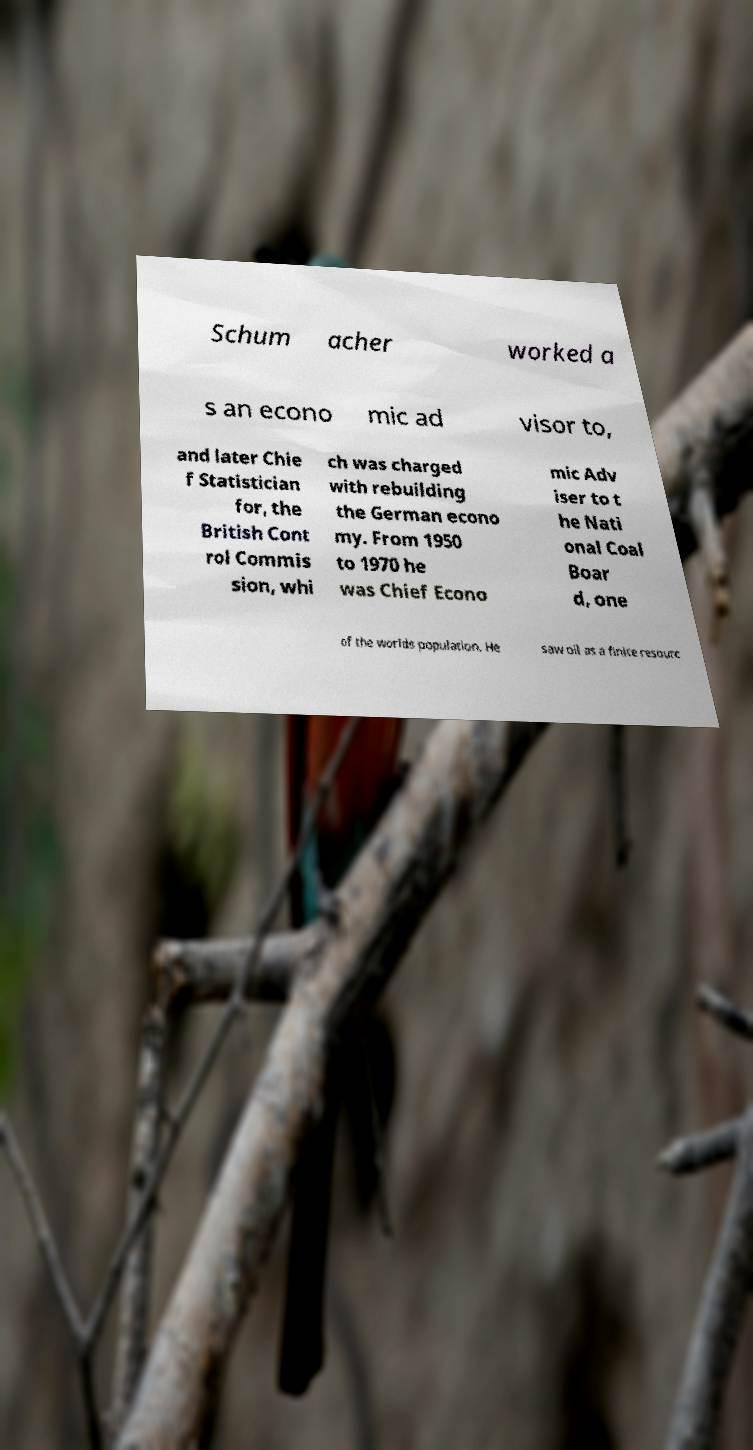I need the written content from this picture converted into text. Can you do that? Schum acher worked a s an econo mic ad visor to, and later Chie f Statistician for, the British Cont rol Commis sion, whi ch was charged with rebuilding the German econo my. From 1950 to 1970 he was Chief Econo mic Adv iser to t he Nati onal Coal Boar d, one of the worlds population. He saw oil as a finite resourc 